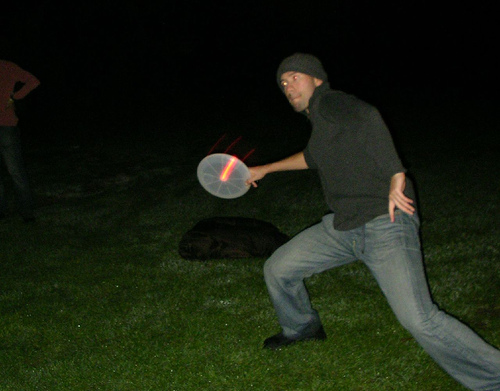<image>What type of shoes is he wearing? The image does not show any shoes. However, if there were any, they might be tennis shoes or sneakers. What would this by like to hit? It is ambiguous what it would be like to hit this. It could be either painful or hard. What type of shoes is he wearing? There are different types of shoes being described. It is ambiguous what type of shoes he is wearing. What would this by like to hit? I don't know what it would be like to hit. It can be painful, fun, hard or target. 